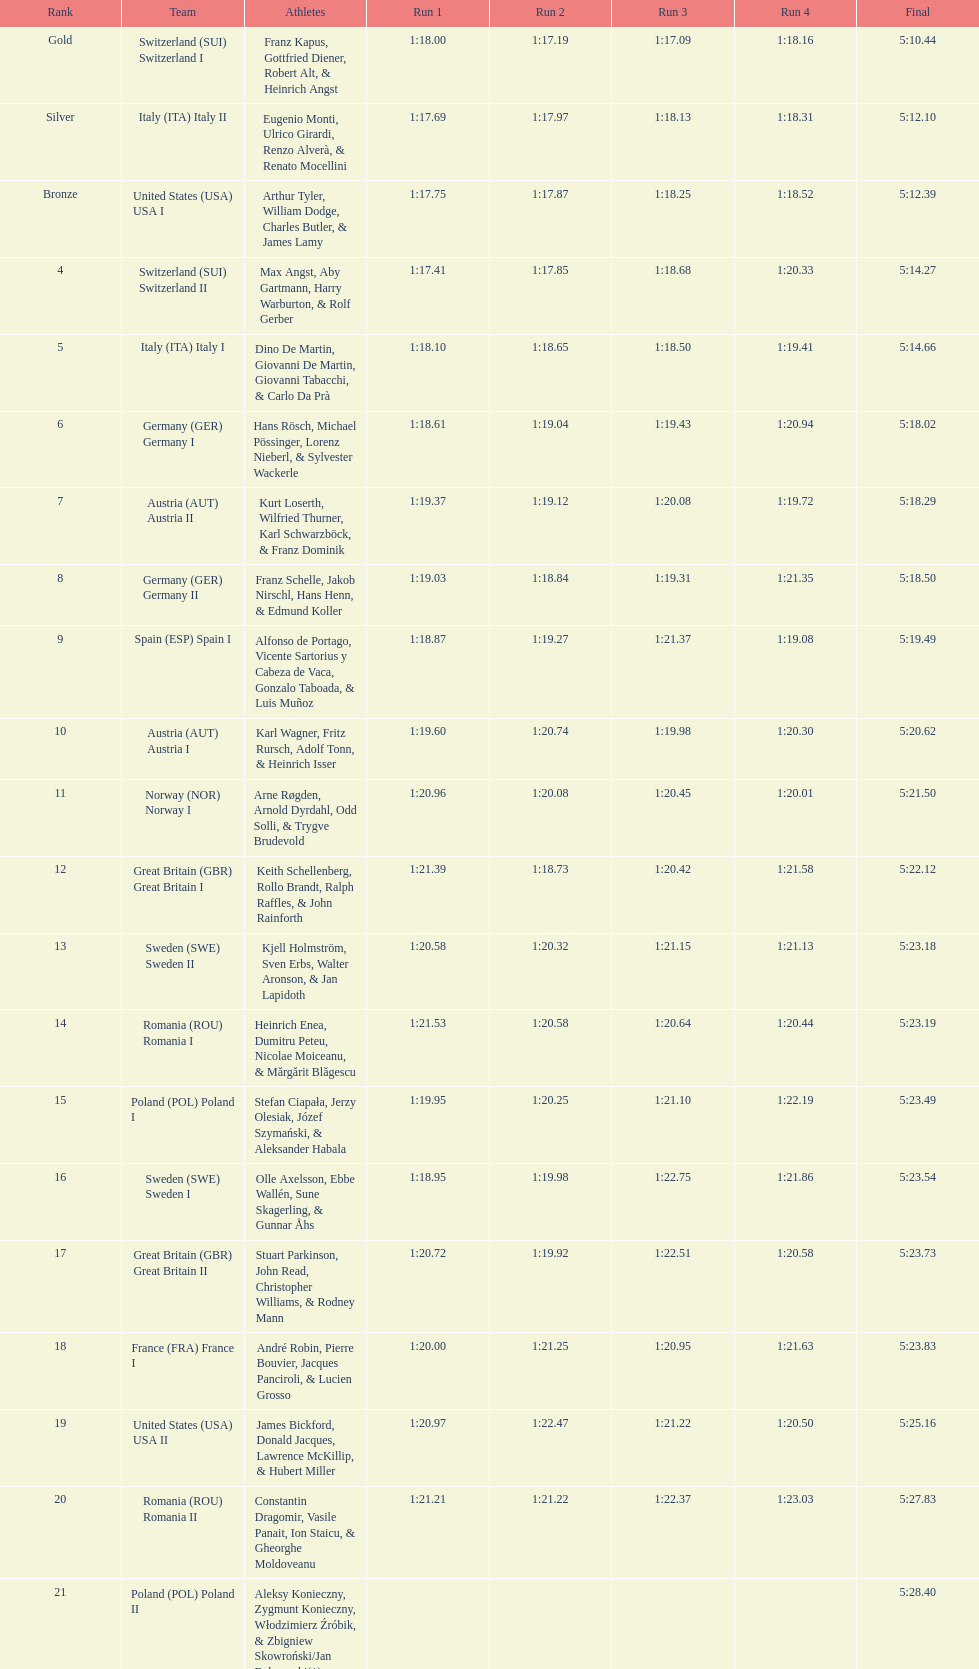Prior to italy (ita) italy ii, who was the previous team? Switzerland (SUI) Switzerland I. 